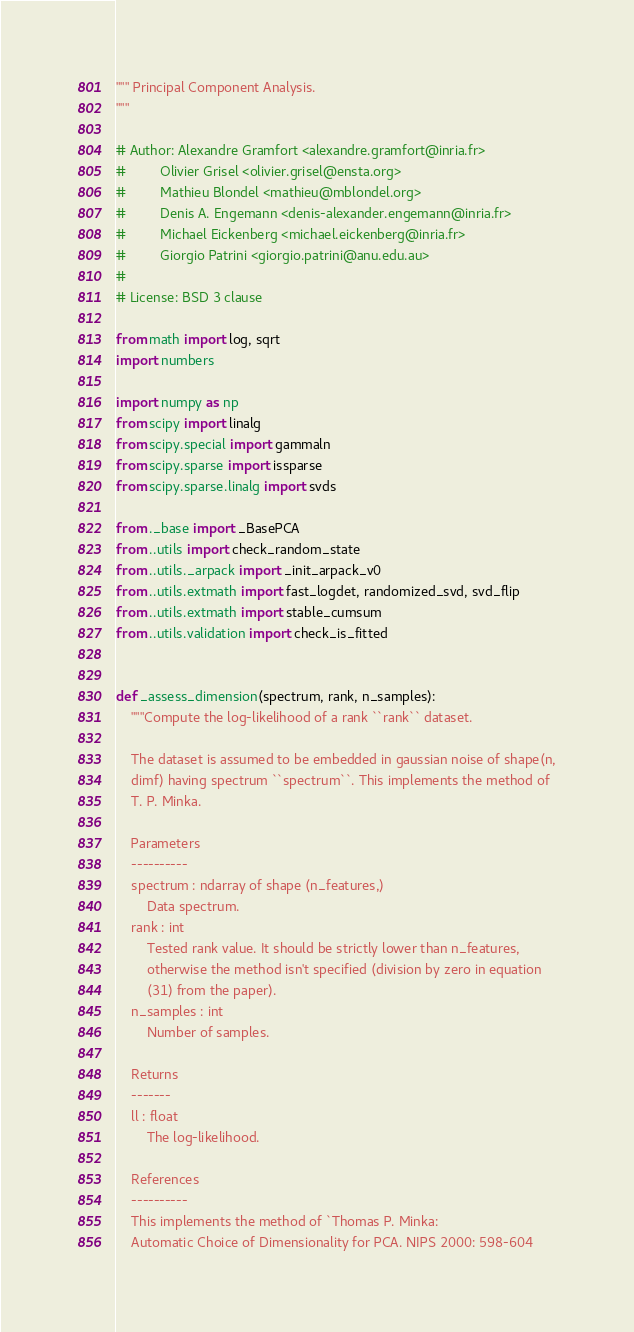Convert code to text. <code><loc_0><loc_0><loc_500><loc_500><_Python_>""" Principal Component Analysis.
"""

# Author: Alexandre Gramfort <alexandre.gramfort@inria.fr>
#         Olivier Grisel <olivier.grisel@ensta.org>
#         Mathieu Blondel <mathieu@mblondel.org>
#         Denis A. Engemann <denis-alexander.engemann@inria.fr>
#         Michael Eickenberg <michael.eickenberg@inria.fr>
#         Giorgio Patrini <giorgio.patrini@anu.edu.au>
#
# License: BSD 3 clause

from math import log, sqrt
import numbers

import numpy as np
from scipy import linalg
from scipy.special import gammaln
from scipy.sparse import issparse
from scipy.sparse.linalg import svds

from ._base import _BasePCA
from ..utils import check_random_state
from ..utils._arpack import _init_arpack_v0
from ..utils.extmath import fast_logdet, randomized_svd, svd_flip
from ..utils.extmath import stable_cumsum
from ..utils.validation import check_is_fitted


def _assess_dimension(spectrum, rank, n_samples):
    """Compute the log-likelihood of a rank ``rank`` dataset.

    The dataset is assumed to be embedded in gaussian noise of shape(n,
    dimf) having spectrum ``spectrum``. This implements the method of
    T. P. Minka.

    Parameters
    ----------
    spectrum : ndarray of shape (n_features,)
        Data spectrum.
    rank : int
        Tested rank value. It should be strictly lower than n_features,
        otherwise the method isn't specified (division by zero in equation
        (31) from the paper).
    n_samples : int
        Number of samples.

    Returns
    -------
    ll : float
        The log-likelihood.

    References
    ----------
    This implements the method of `Thomas P. Minka:
    Automatic Choice of Dimensionality for PCA. NIPS 2000: 598-604</code> 